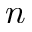<formula> <loc_0><loc_0><loc_500><loc_500>n</formula> 